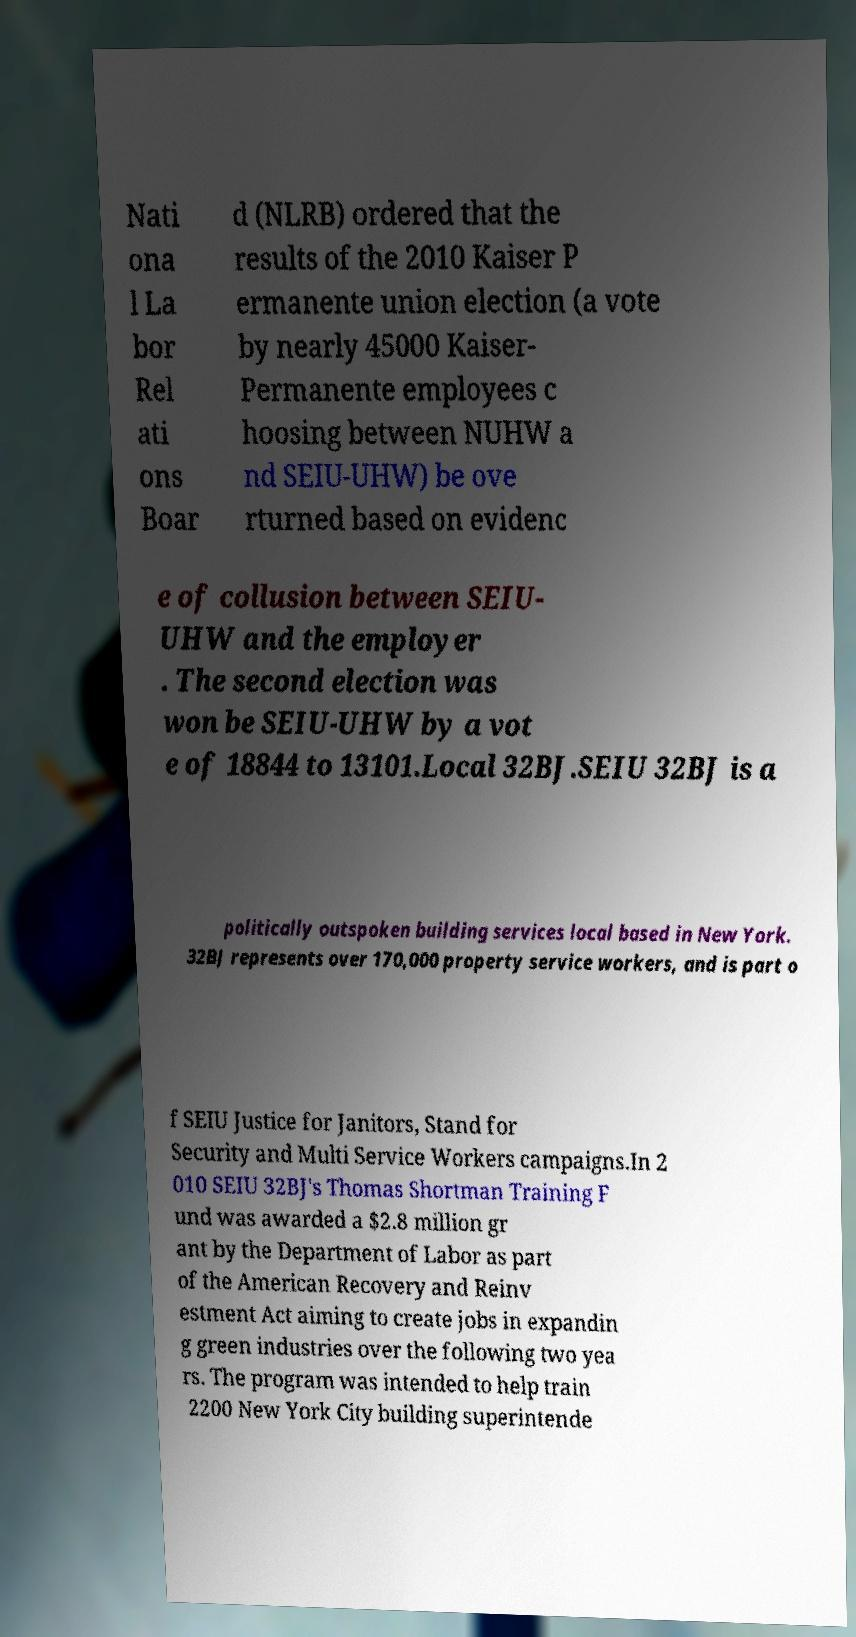For documentation purposes, I need the text within this image transcribed. Could you provide that? Nati ona l La bor Rel ati ons Boar d (NLRB) ordered that the results of the 2010 Kaiser P ermanente union election (a vote by nearly 45000 Kaiser- Permanente employees c hoosing between NUHW a nd SEIU-UHW) be ove rturned based on evidenc e of collusion between SEIU- UHW and the employer . The second election was won be SEIU-UHW by a vot e of 18844 to 13101.Local 32BJ.SEIU 32BJ is a politically outspoken building services local based in New York. 32BJ represents over 170,000 property service workers, and is part o f SEIU Justice for Janitors, Stand for Security and Multi Service Workers campaigns.In 2 010 SEIU 32BJ's Thomas Shortman Training F und was awarded a $2.8 million gr ant by the Department of Labor as part of the American Recovery and Reinv estment Act aiming to create jobs in expandin g green industries over the following two yea rs. The program was intended to help train 2200 New York City building superintende 